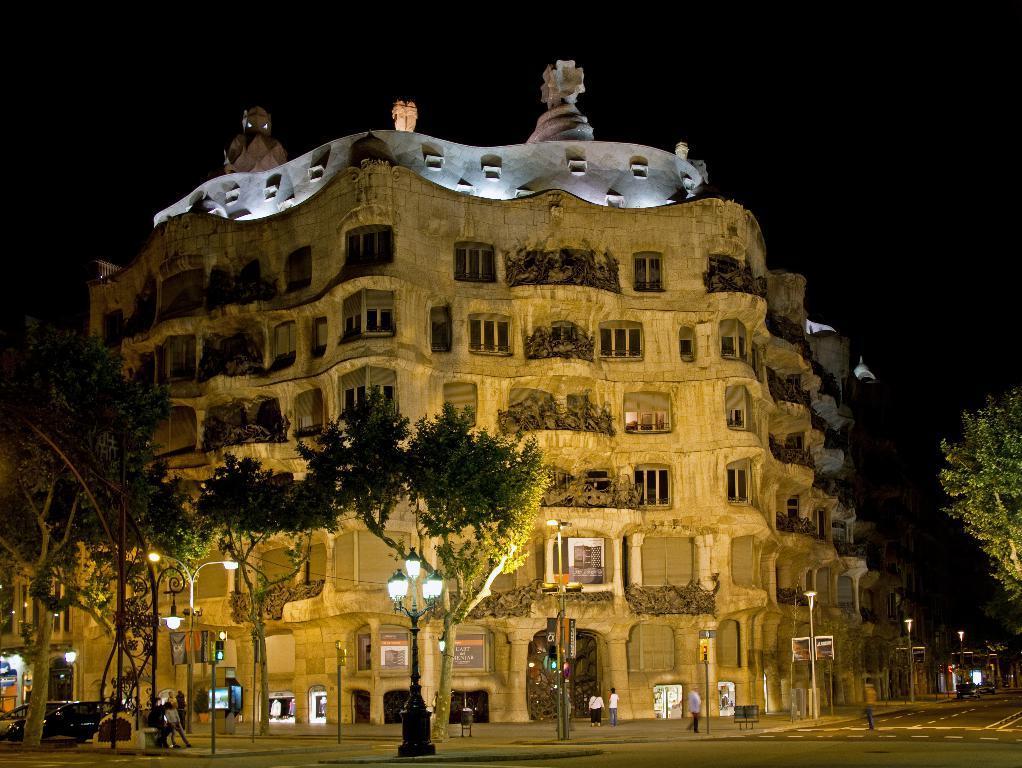How would you summarize this image in a sentence or two? This picture is clicked outside the city. Here, we see people walking on the road. Beside them, we see traffic signals and we even see street lights and poles. On either side of the road, we see trees, There is a black car moving on the road and in the background, we see a building which is white in color. At the top of the picture, it is black in color and this picture might be clicked in the dark. 